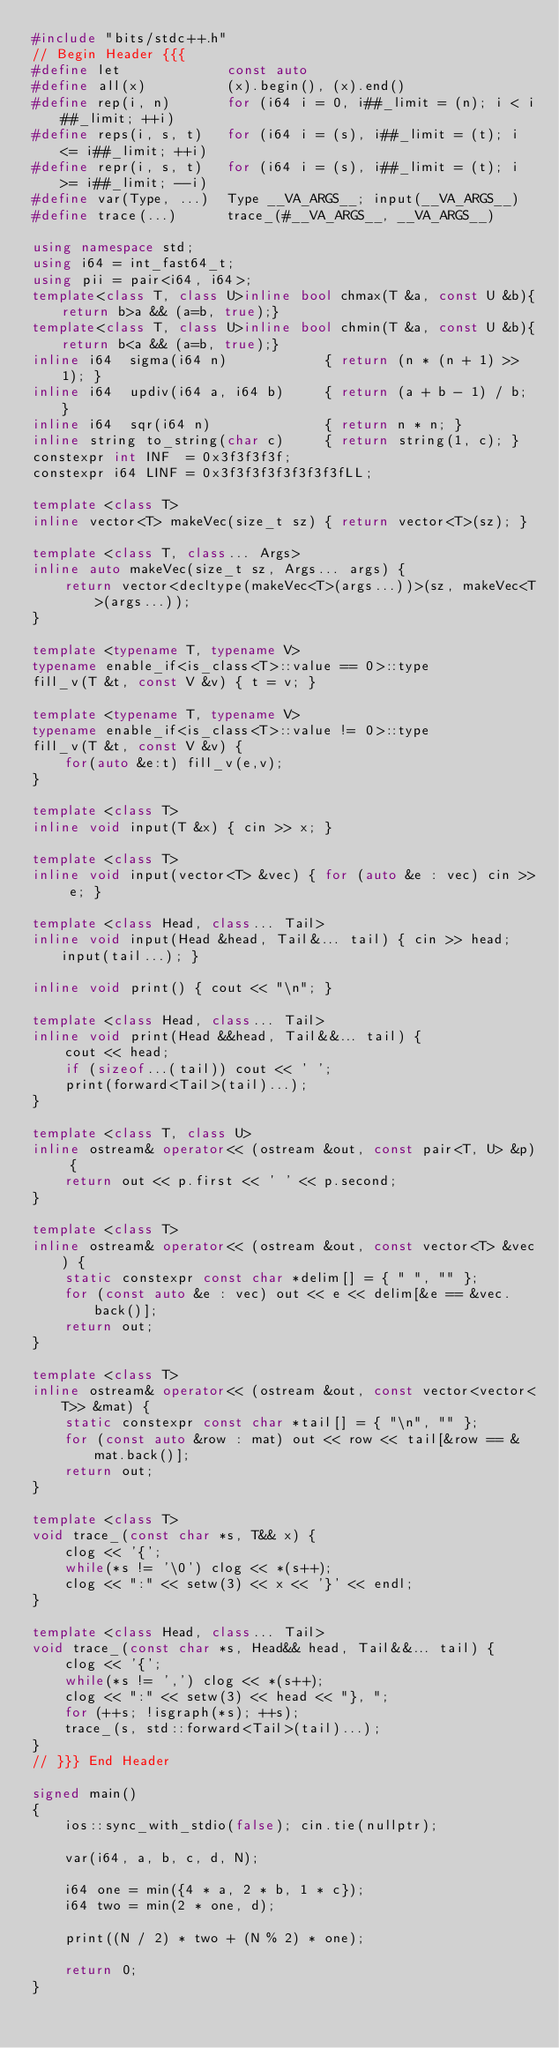Convert code to text. <code><loc_0><loc_0><loc_500><loc_500><_C++_>#include "bits/stdc++.h"
// Begin Header {{{
#define let             const auto
#define all(x)          (x).begin(), (x).end()
#define rep(i, n)       for (i64 i = 0, i##_limit = (n); i < i##_limit; ++i)
#define reps(i, s, t)   for (i64 i = (s), i##_limit = (t); i <= i##_limit; ++i)
#define repr(i, s, t)   for (i64 i = (s), i##_limit = (t); i >= i##_limit; --i)
#define var(Type, ...)  Type __VA_ARGS__; input(__VA_ARGS__)
#define trace(...)      trace_(#__VA_ARGS__, __VA_ARGS__)

using namespace std;
using i64 = int_fast64_t;
using pii = pair<i64, i64>;
template<class T, class U>inline bool chmax(T &a, const U &b){return b>a && (a=b, true);}
template<class T, class U>inline bool chmin(T &a, const U &b){return b<a && (a=b, true);}
inline i64  sigma(i64 n)            { return (n * (n + 1) >> 1); }
inline i64  updiv(i64 a, i64 b)     { return (a + b - 1) / b; }
inline i64  sqr(i64 n)              { return n * n; }
inline string to_string(char c)     { return string(1, c); }
constexpr int INF  = 0x3f3f3f3f;
constexpr i64 LINF = 0x3f3f3f3f3f3f3f3fLL;

template <class T>
inline vector<T> makeVec(size_t sz) { return vector<T>(sz); }

template <class T, class... Args>
inline auto makeVec(size_t sz, Args... args) {
    return vector<decltype(makeVec<T>(args...))>(sz, makeVec<T>(args...));
}

template <typename T, typename V>
typename enable_if<is_class<T>::value == 0>::type
fill_v(T &t, const V &v) { t = v; }

template <typename T, typename V>
typename enable_if<is_class<T>::value != 0>::type
fill_v(T &t, const V &v) {
    for(auto &e:t) fill_v(e,v);
}

template <class T>
inline void input(T &x) { cin >> x; }

template <class T>
inline void input(vector<T> &vec) { for (auto &e : vec) cin >> e; }

template <class Head, class... Tail>
inline void input(Head &head, Tail&... tail) { cin >> head; input(tail...); }

inline void print() { cout << "\n"; }

template <class Head, class... Tail>
inline void print(Head &&head, Tail&&... tail) {
    cout << head;
    if (sizeof...(tail)) cout << ' ';
    print(forward<Tail>(tail)...);
}

template <class T, class U>
inline ostream& operator<< (ostream &out, const pair<T, U> &p) {
    return out << p.first << ' ' << p.second;
}

template <class T>
inline ostream& operator<< (ostream &out, const vector<T> &vec) {
    static constexpr const char *delim[] = { " ", "" };
    for (const auto &e : vec) out << e << delim[&e == &vec.back()];
    return out;
}

template <class T>
inline ostream& operator<< (ostream &out, const vector<vector<T>> &mat) {
    static constexpr const char *tail[] = { "\n", "" };
    for (const auto &row : mat) out << row << tail[&row == &mat.back()];
    return out;
}

template <class T>
void trace_(const char *s, T&& x) {
    clog << '{';
    while(*s != '\0') clog << *(s++);
    clog << ":" << setw(3) << x << '}' << endl;
}

template <class Head, class... Tail>
void trace_(const char *s, Head&& head, Tail&&... tail) {
    clog << '{';
    while(*s != ',') clog << *(s++);
    clog << ":" << setw(3) << head << "}, ";
    for (++s; !isgraph(*s); ++s);
    trace_(s, std::forward<Tail>(tail)...);
}
// }}} End Header

signed main()
{
    ios::sync_with_stdio(false); cin.tie(nullptr);

    var(i64, a, b, c, d, N);

    i64 one = min({4 * a, 2 * b, 1 * c});
    i64 two = min(2 * one, d);

    print((N / 2) * two + (N % 2) * one);

    return 0;
}
</code> 